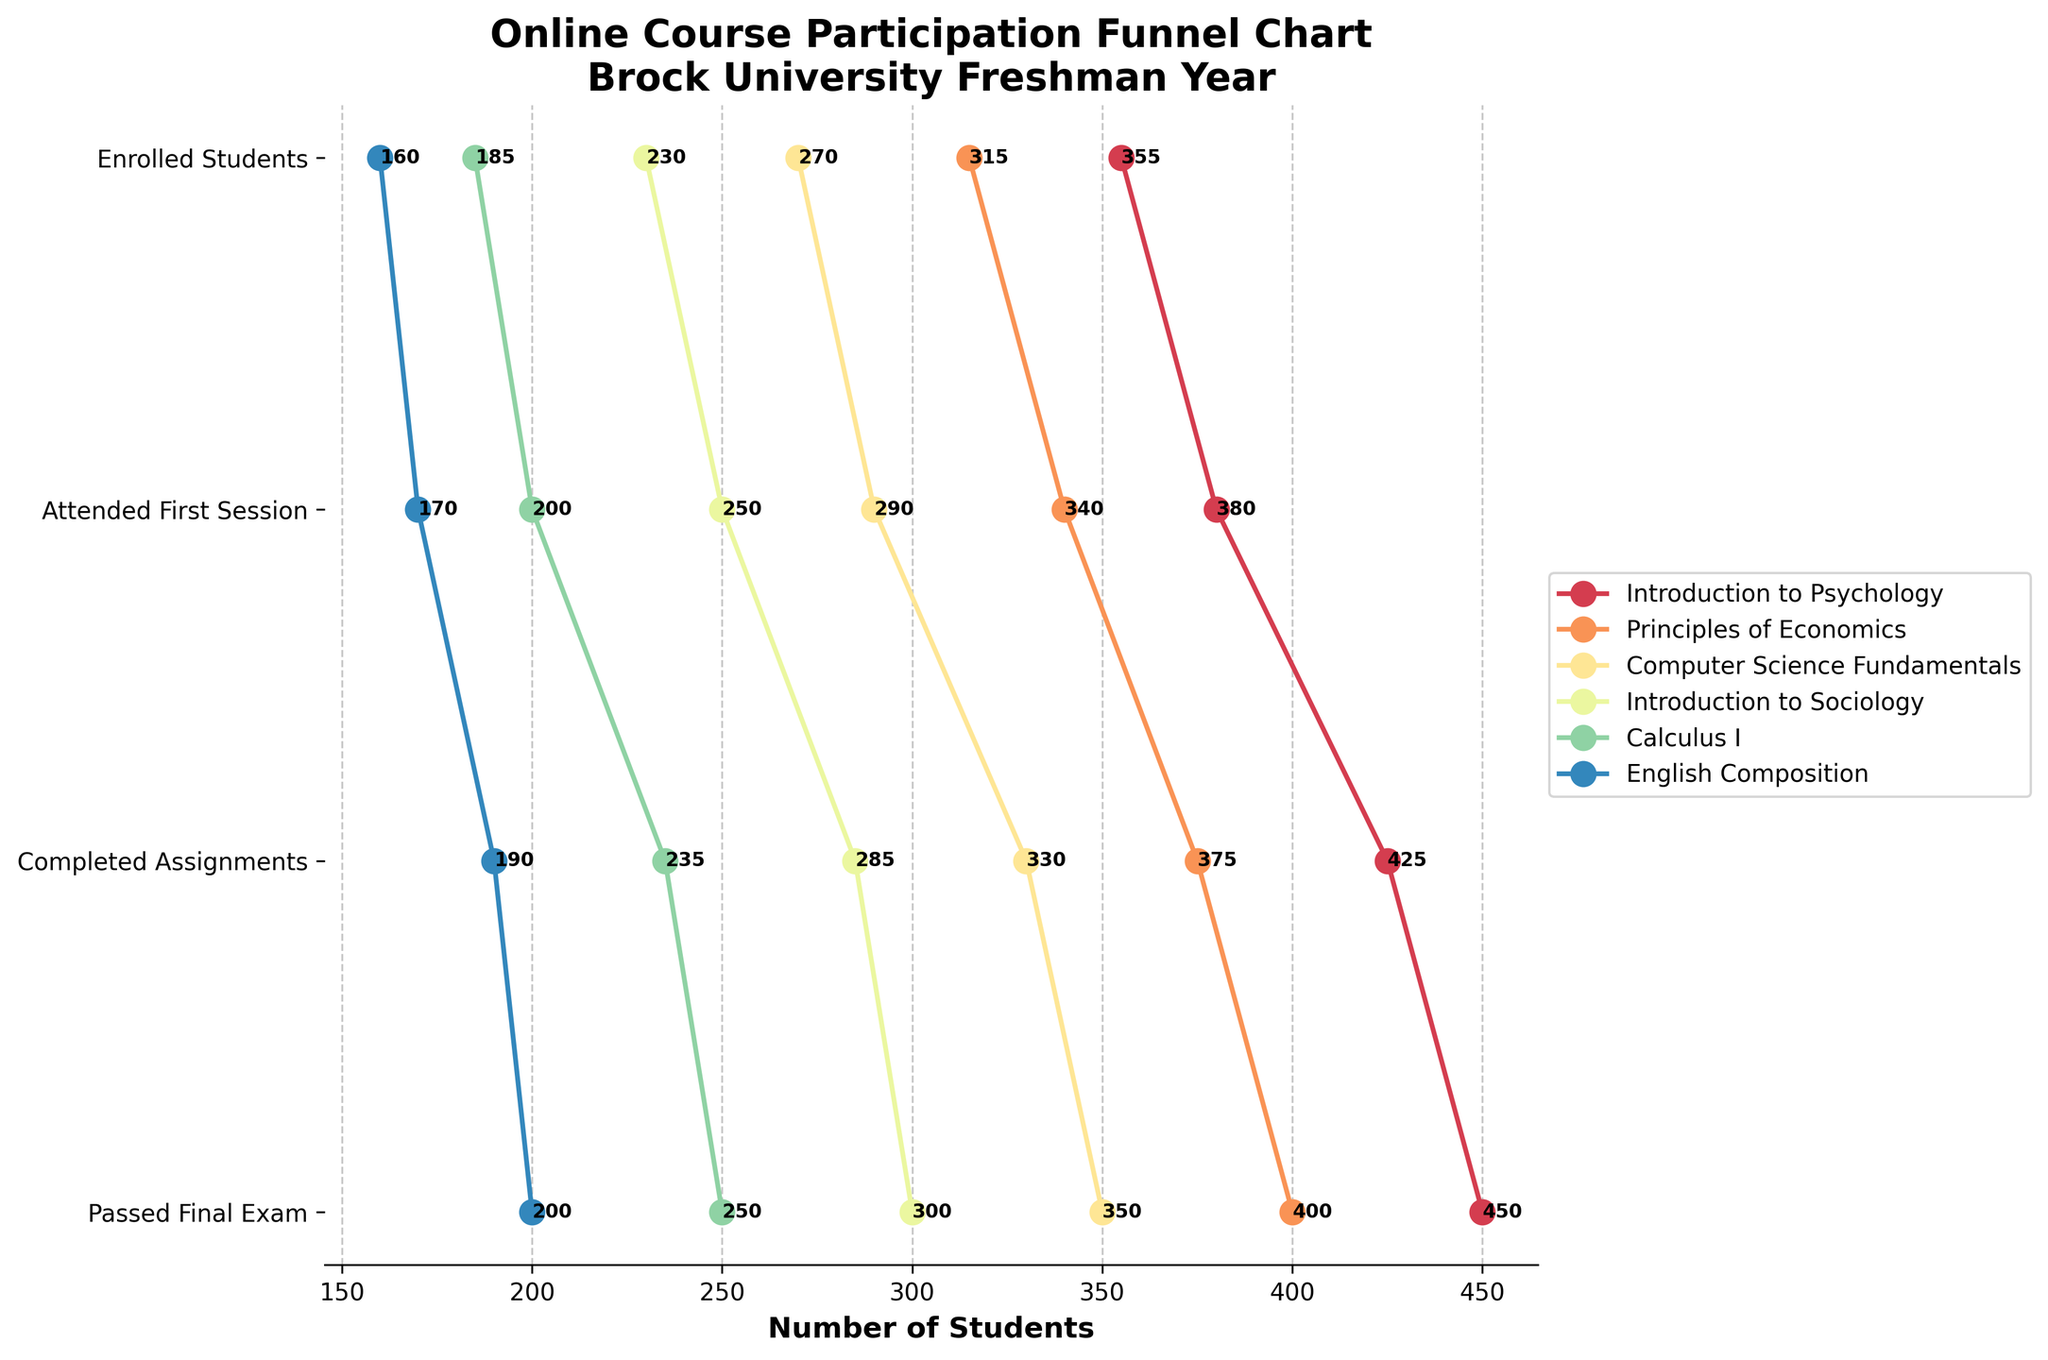What is the title of the plot? The title is located at the top of the plot and summarizes the figure's content.
Answer: Online Course Participation Funnel Chart\nBrock University Freshman Year How many subjects are represented in the chart? The number of data series on the chart corresponds to the number of subjects. There are six lines/colors, one for each subject.
Answer: Six Which stage has the highest number of students in "Introduction to Sociology"? By following the line for "Introduction to Sociology," you can see that the leftmost data point (Enrolled Students) has the highest value.
Answer: Enrolled Students Which subject has the least number of students passed the final exam? By looking at the "Passed Final Exam" data points for all subjects, "English Composition" has the lowest value at 160.
Answer: English Composition How many students completed assignments in "Calculus I"? Find the data points for "Calculus I" and locate the "Completed Assignments" point, which is 200.
Answer: 200 What is the difference between the number of students who attended the first session and those who passed the final exam for "Principles of Economics"? Subtract the number of students who passed the final exam (315) from those who attended the first session (375), resulting in a difference of 60.
Answer: 60 Among all subjects, which one has the smallest drop-off rate from "Completed Assignments" to "Passed Final Exam"? Compare the drop-off rates by subtracting "Passed Final Exam" from "Completed Assignments" for each subject. "Computer Science Fundamentals" has the smallest drop-off with 290 - 270 = 20.
Answer: Computer Science Fundamentals Which subject shows the highest student participation in the "Attended First Session" stage? Identify the data points for "Attended First Session" for all subjects. "Introduction to Psychology" has the highest value at 425.
Answer: Introduction to Psychology What is the sum of students who passed the final exam in "Introduction to Psychology" and "Introduction to Sociology"? Add the number of students who passed the final exam in both subjects: 355 (Introduction to Psychology) + 230 (Introduction to Sociology) = 585.
Answer: 585 Which subject shows a more significant drop from "Enrolled Students" to "Completed Assignments," "Calculus I" or "English Composition"? Calculate the drop for each subject: "Calculus I" has a drop from 250 to 200 (50 students) and "English Composition" from 200 to 170 (30 students). The more significant drop is in "Calculus I."
Answer: Calculus I 